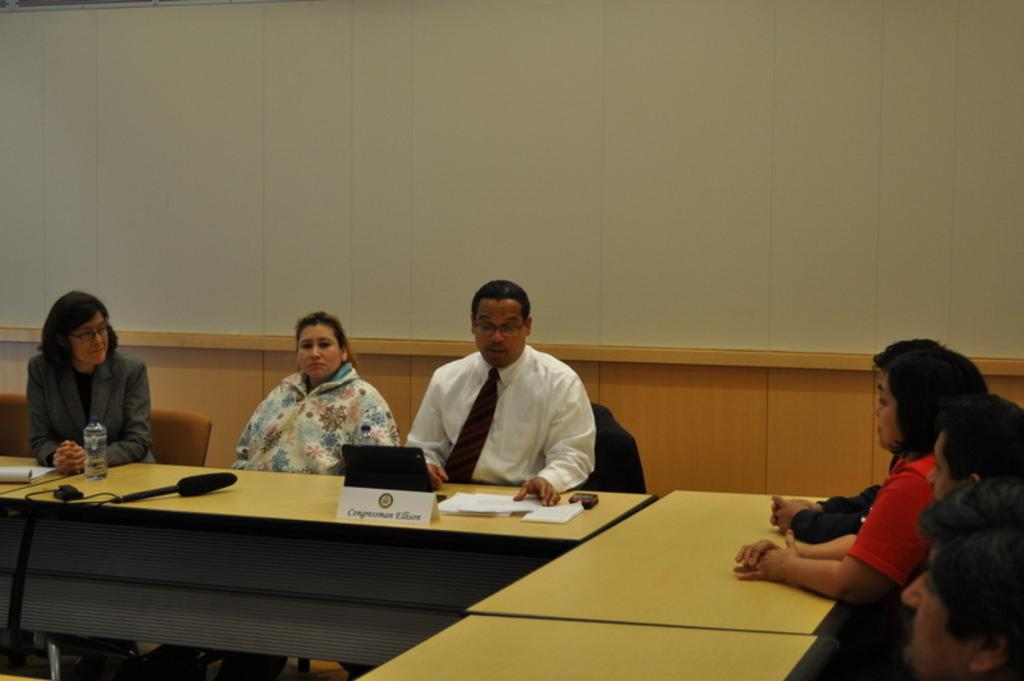What are the persons in the image doing? The persons in the image are sitting on a chair. What can be seen on the table in the image? There is a mic, a bottle, a book, and papers on the table. What might be used for amplifying sound in the image? There is a mic on the table, which can be used for amplifying sound. How many girls are present in the image? The provided facts do not mention any girls in the image. What is the uncle doing in the image? The provided facts do not mention any uncles in the image. 